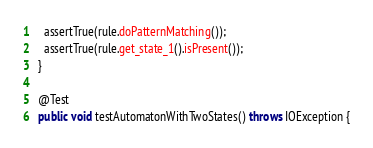<code> <loc_0><loc_0><loc_500><loc_500><_Java_>    assertTrue(rule.doPatternMatching());
    assertTrue(rule.get_state_1().isPresent());
  }

  @Test
  public void testAutomatonWithTwoStates() throws IOException {</code> 